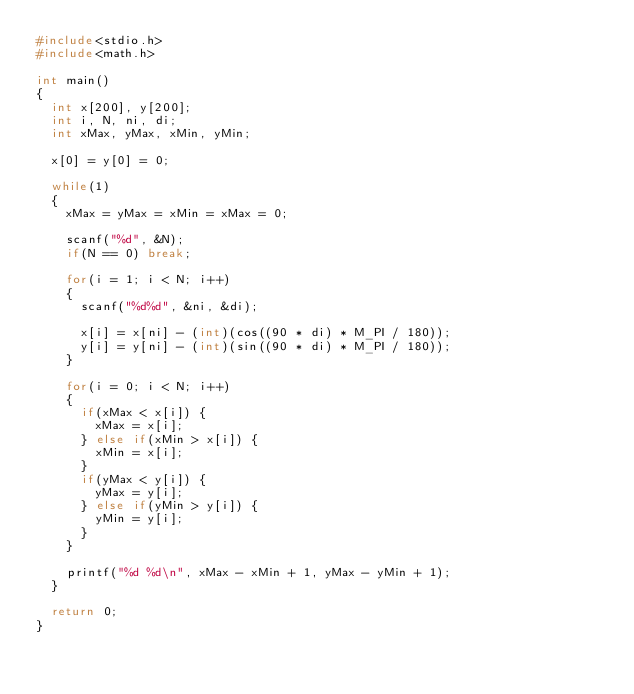Convert code to text. <code><loc_0><loc_0><loc_500><loc_500><_C_>#include<stdio.h>
#include<math.h>

int main()
{
	int x[200], y[200];
	int i, N, ni, di;
	int xMax, yMax, xMin, yMin;
	
	x[0] = y[0] = 0;
	
	while(1)
	{
		xMax = yMax = xMin = xMax = 0;
		
		scanf("%d", &N);
		if(N == 0) break;
		
		for(i = 1; i < N; i++)
		{
			scanf("%d%d", &ni, &di);
			
			x[i] = x[ni] - (int)(cos((90 * di) * M_PI / 180));
			y[i] = y[ni] - (int)(sin((90 * di) * M_PI / 180));
		}
		
		for(i = 0; i < N; i++)
		{
			if(xMax < x[i]) {
				xMax = x[i];
			} else if(xMin > x[i]) {
				xMin = x[i];
			}
			if(yMax < y[i]) {
				yMax = y[i];
			} else if(yMin > y[i]) {
				yMin = y[i];
			}
		}
		
		printf("%d %d\n", xMax - xMin + 1, yMax - yMin + 1);
	}
	
	return 0;
}</code> 